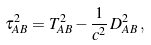<formula> <loc_0><loc_0><loc_500><loc_500>\tau _ { A B } ^ { 2 } = T _ { A B } ^ { 2 } - \frac { 1 } { c ^ { 2 } } \, D _ { A B } ^ { 2 } \, ,</formula> 